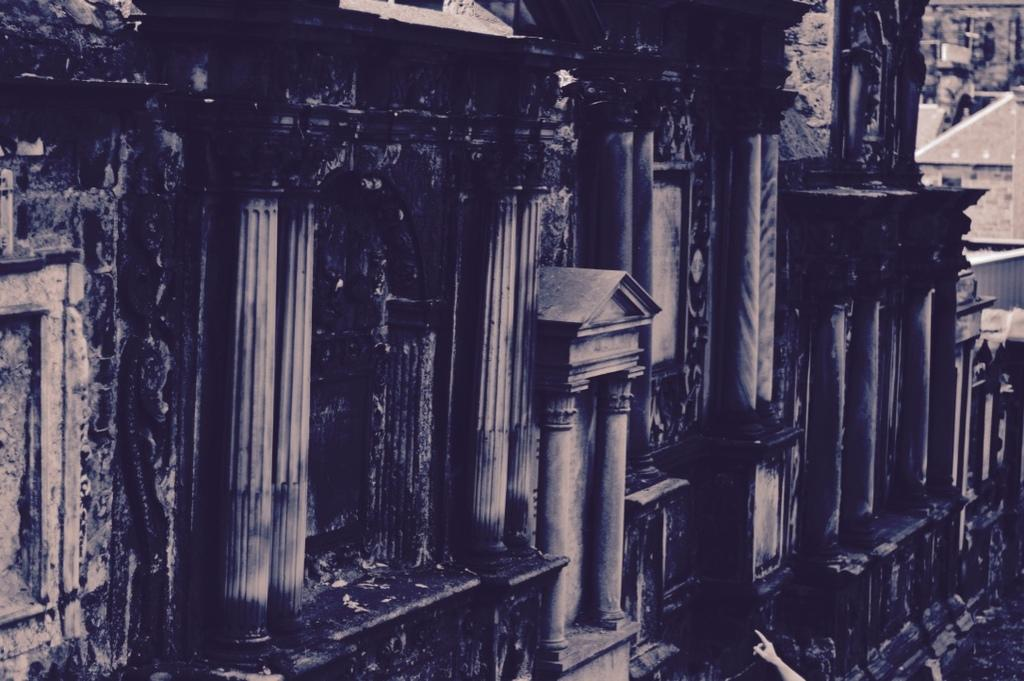What is the color scheme of the image? The image is black and white. What is the main subject of the image? The image depicts an old monument. What type of collar is visible on the monument in the image? There is no collar present on the monument in the image, as it is an inanimate structure. 